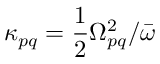<formula> <loc_0><loc_0><loc_500><loc_500>\kappa _ { p q } = \frac { 1 } { 2 } \Omega _ { p q } ^ { 2 } / \bar { \omega }</formula> 